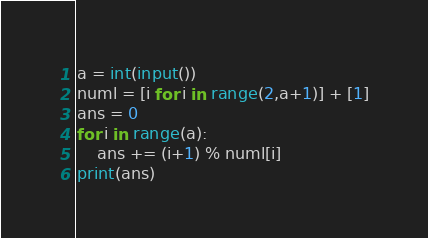<code> <loc_0><loc_0><loc_500><loc_500><_Python_>a = int(input())
numl = [i for i in range(2,a+1)] + [1]
ans = 0
for i in range(a):
    ans += (i+1) % numl[i]
print(ans)</code> 